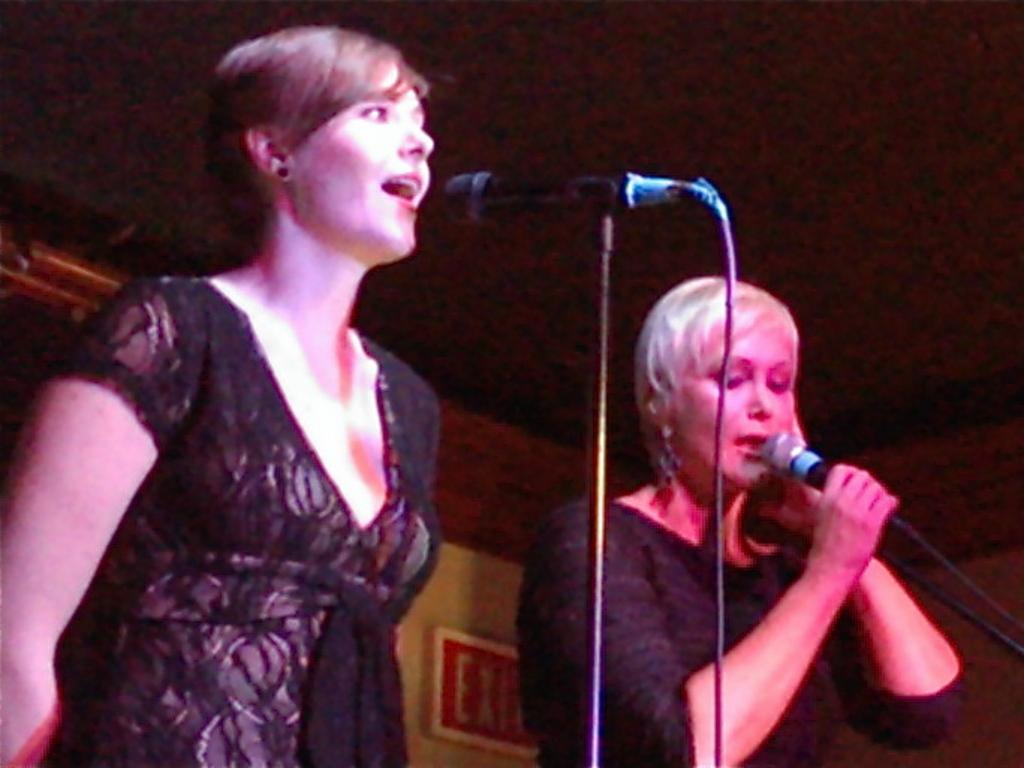How many people are in the image? There are two women in the image. What are the women doing in the image? The women are singing in the image. What objects are the women using while singing? The women are using microphones in the image. What color is the copper wire used by the women in the image? There is no copper wire present in the image; the women are using microphones, not copper wires. 